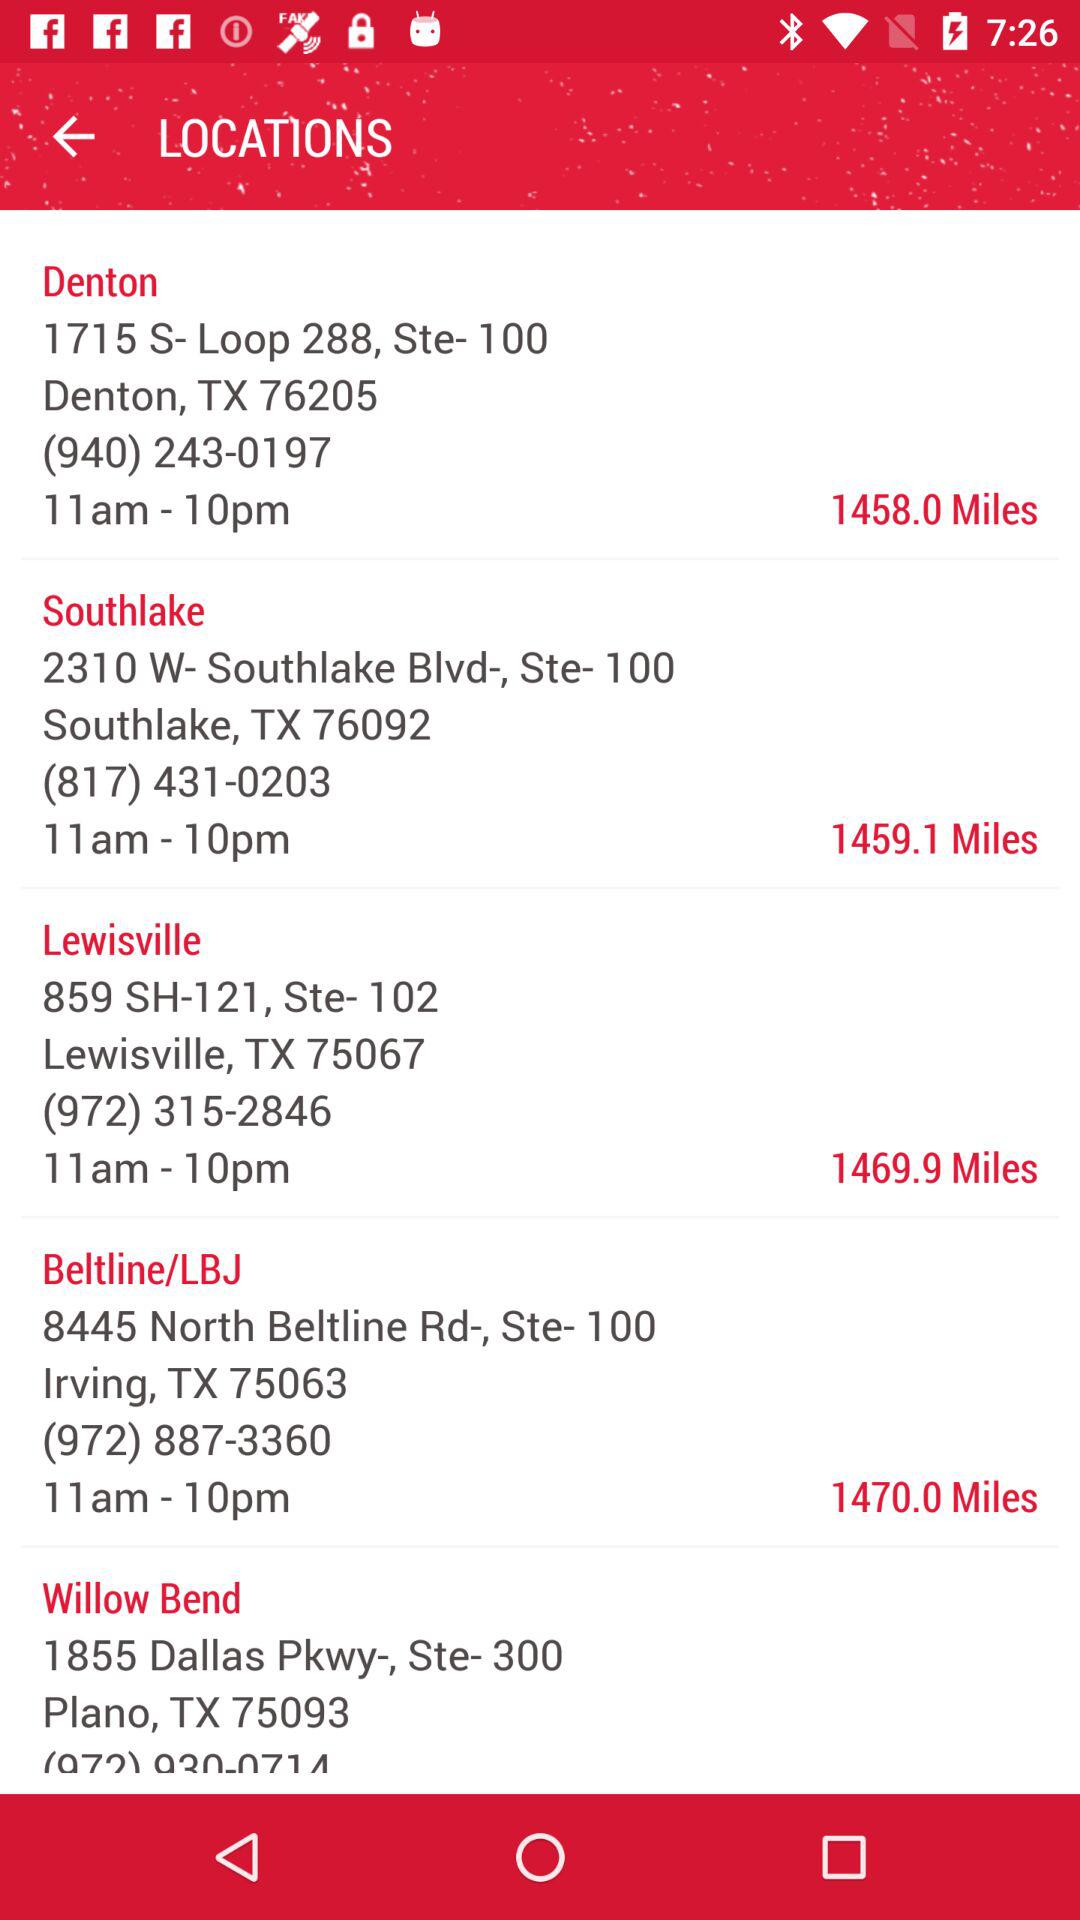What is the contact number for Southlake? The contact number for Southlake is (817) 431-0203. 